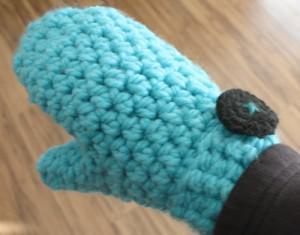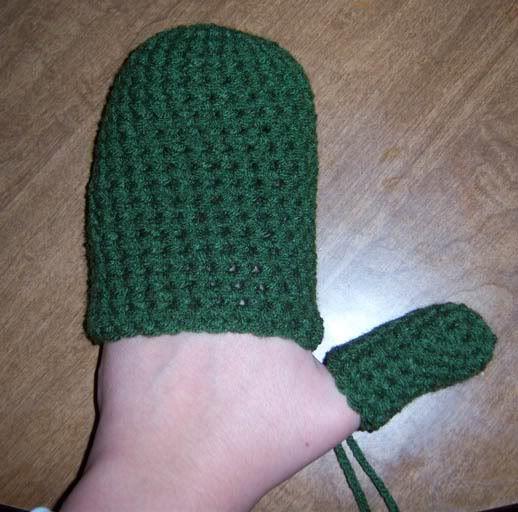The first image is the image on the left, the second image is the image on the right. For the images displayed, is the sentence "There are no less than three mittens" factually correct? Answer yes or no. No. 